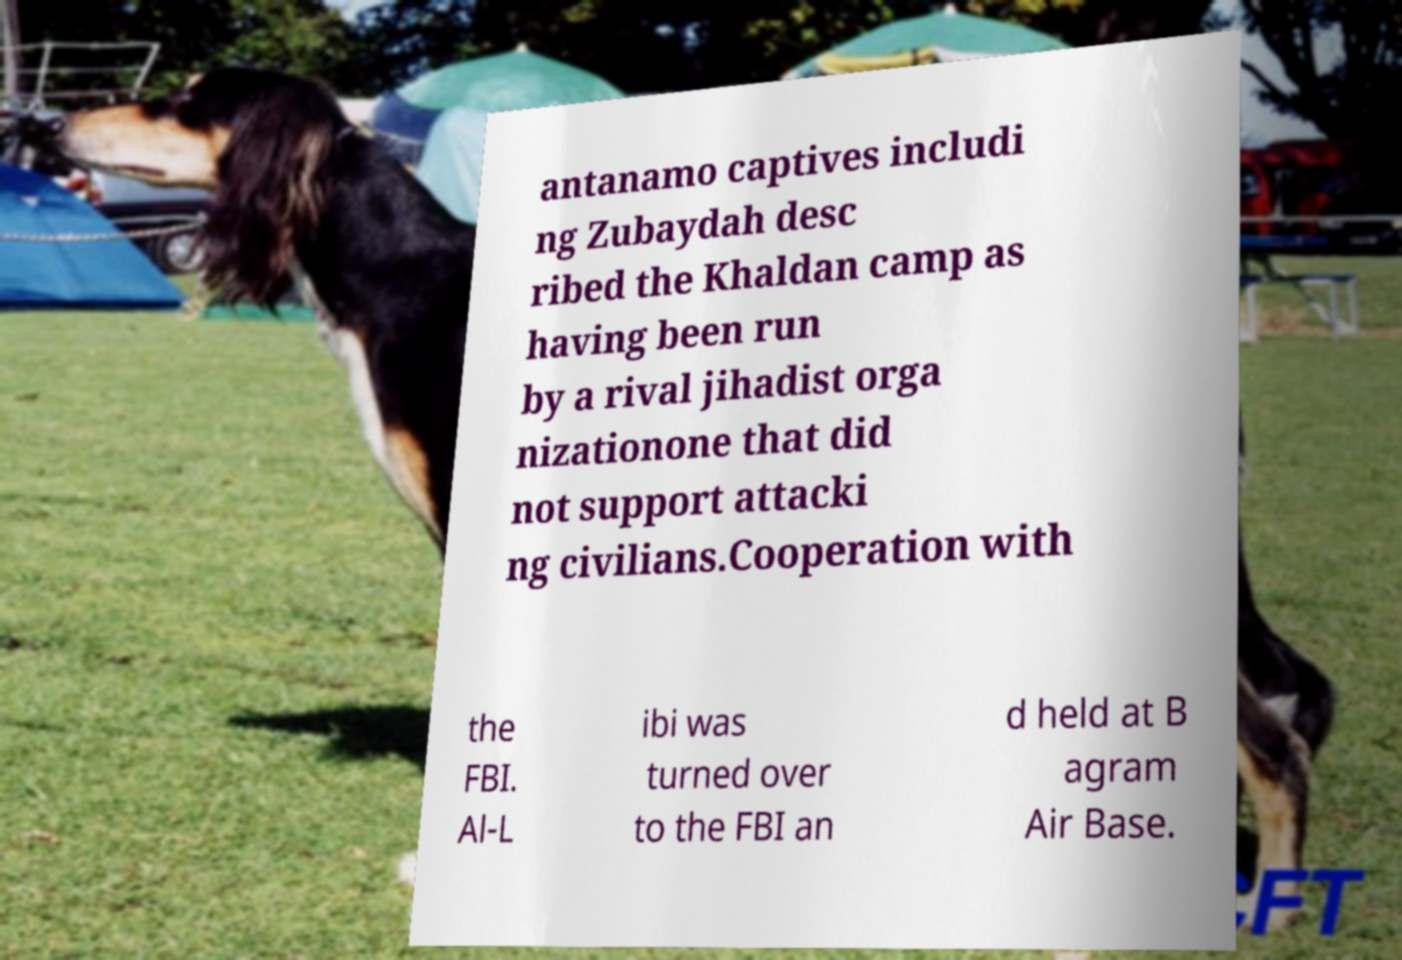Can you read and provide the text displayed in the image?This photo seems to have some interesting text. Can you extract and type it out for me? antanamo captives includi ng Zubaydah desc ribed the Khaldan camp as having been run by a rival jihadist orga nizationone that did not support attacki ng civilians.Cooperation with the FBI. Al-L ibi was turned over to the FBI an d held at B agram Air Base. 